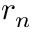Convert formula to latex. <formula><loc_0><loc_0><loc_500><loc_500>r _ { n }</formula> 